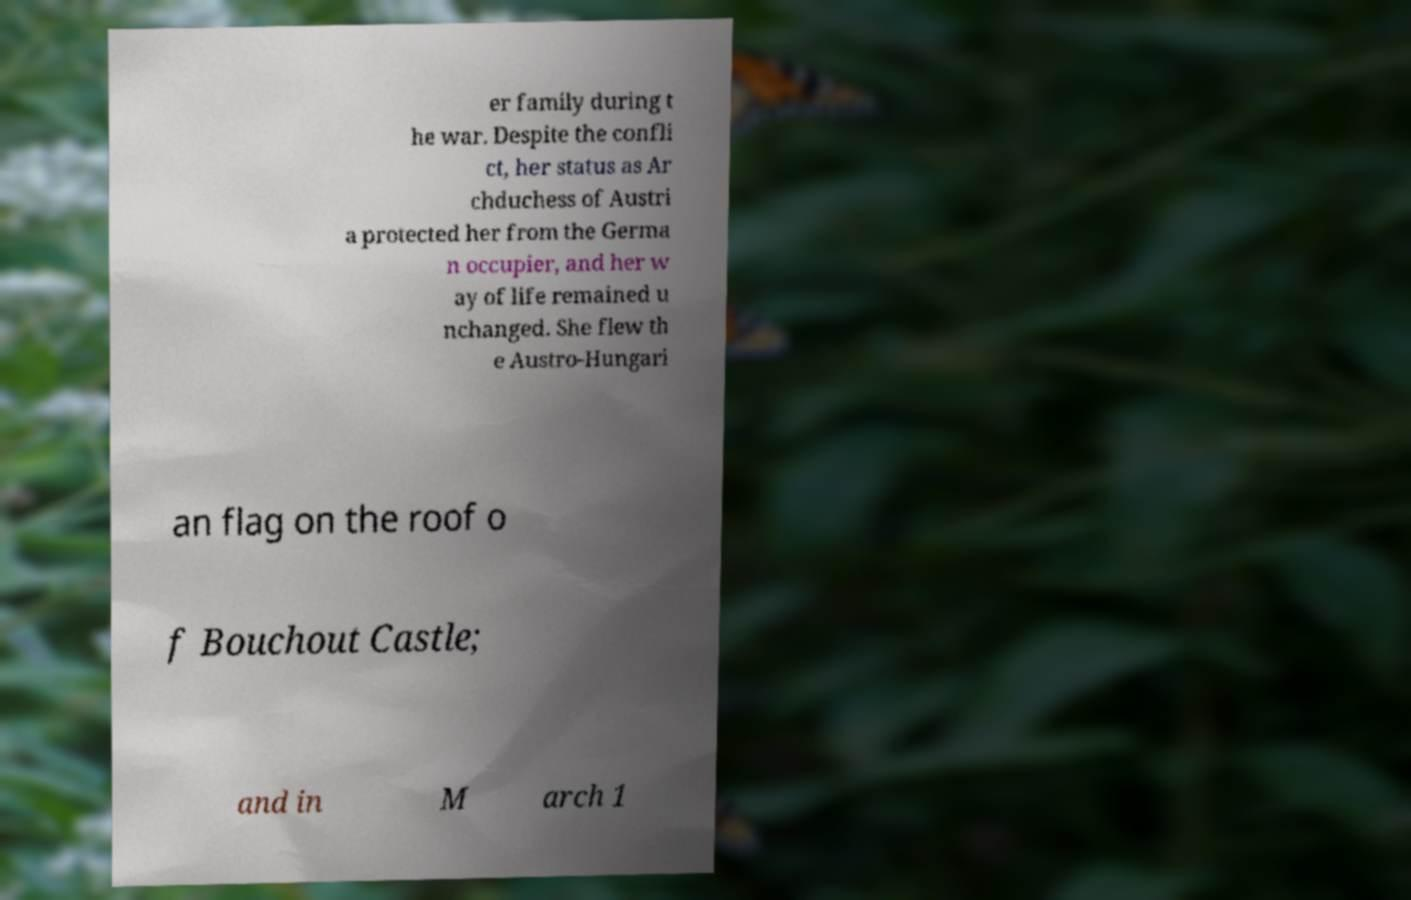Could you assist in decoding the text presented in this image and type it out clearly? er family during t he war. Despite the confli ct, her status as Ar chduchess of Austri a protected her from the Germa n occupier, and her w ay of life remained u nchanged. She flew th e Austro-Hungari an flag on the roof o f Bouchout Castle; and in M arch 1 